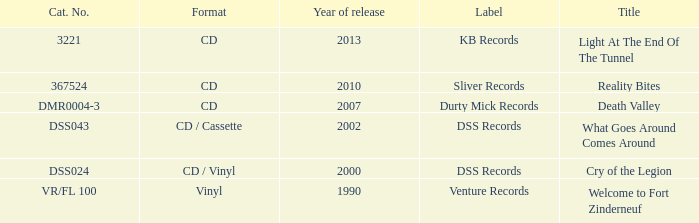I'm looking to parse the entire table for insights. Could you assist me with that? {'header': ['Cat. No.', 'Format', 'Year of release', 'Label', 'Title'], 'rows': [['3221', 'CD', '2013', 'KB Records', 'Light At The End Of The Tunnel'], ['367524', 'CD', '2010', 'Sliver Records', 'Reality Bites'], ['DMR0004-3', 'CD', '2007', 'Durty Mick Records', 'Death Valley'], ['DSS043', 'CD / Cassette', '2002', 'DSS Records', 'What Goes Around Comes Around'], ['DSS024', 'CD / Vinyl', '2000', 'DSS Records', 'Cry of the Legion'], ['VR/FL 100', 'Vinyl', '1990', 'Venture Records', 'Welcome to Fort Zinderneuf']]} What is the latest year of the album with the release title death valley? 2007.0. 